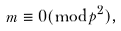<formula> <loc_0><loc_0><loc_500><loc_500>m \equiv 0 ( \bmod p ^ { 2 } ) ,</formula> 